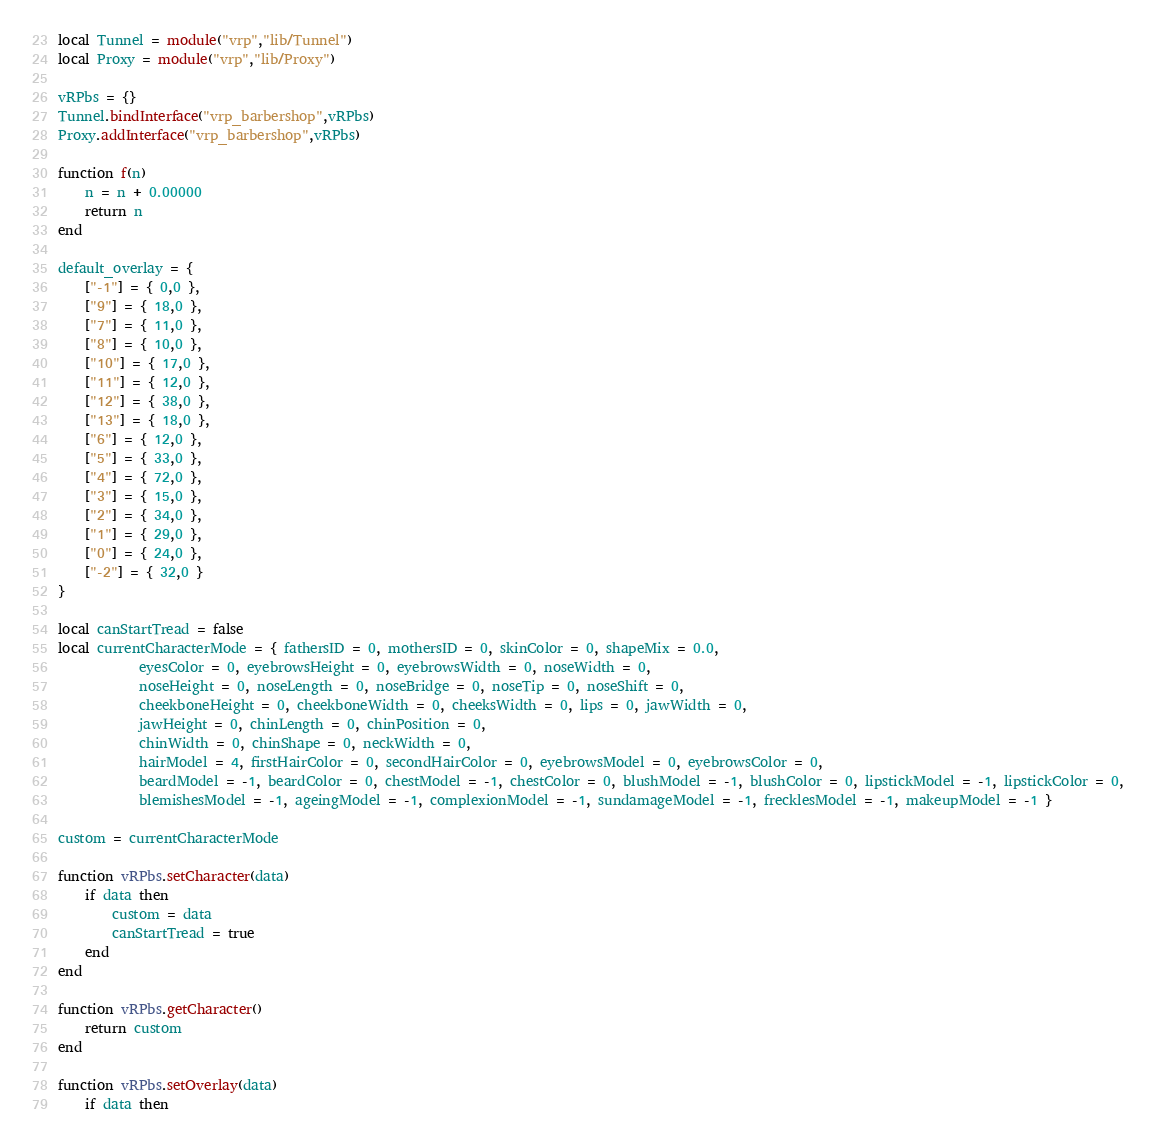<code> <loc_0><loc_0><loc_500><loc_500><_Lua_>local Tunnel = module("vrp","lib/Tunnel")
local Proxy = module("vrp","lib/Proxy")

vRPbs = {}
Tunnel.bindInterface("vrp_barbershop",vRPbs)
Proxy.addInterface("vrp_barbershop",vRPbs)

function f(n)
	n = n + 0.00000
	return n
end

default_overlay = {
	["-1"] = { 0,0 },
	["9"] = { 18,0 },
	["7"] = { 11,0 },
	["8"] = { 10,0 },
	["10"] = { 17,0 },
	["11"] = { 12,0 },
	["12"] = { 38,0 },
	["13"] = { 18,0 },
	["6"] = { 12,0 },
	["5"] = { 33,0 },
	["4"] = { 72,0 },
	["3"] = { 15,0 },
	["2"] = { 34,0 },
	["1"] = { 29,0 },
	["0"] = { 24,0 },
	["-2"] = { 32,0 }
}

local canStartTread = false
local currentCharacterMode = { fathersID = 0, mothersID = 0, skinColor = 0, shapeMix = 0.0,
            eyesColor = 0, eyebrowsHeight = 0, eyebrowsWidth = 0, noseWidth = 0,
            noseHeight = 0, noseLength = 0, noseBridge = 0, noseTip = 0, noseShift = 0,
            cheekboneHeight = 0, cheekboneWidth = 0, cheeksWidth = 0, lips = 0, jawWidth = 0,
            jawHeight = 0, chinLength = 0, chinPosition = 0,
            chinWidth = 0, chinShape = 0, neckWidth = 0,
            hairModel = 4, firstHairColor = 0, secondHairColor = 0, eyebrowsModel = 0, eyebrowsColor = 0,
            beardModel = -1, beardColor = 0, chestModel = -1, chestColor = 0, blushModel = -1, blushColor = 0, lipstickModel = -1, lipstickColor = 0,
            blemishesModel = -1, ageingModel = -1, complexionModel = -1, sundamageModel = -1, frecklesModel = -1, makeupModel = -1 }

custom = currentCharacterMode

function vRPbs.setCharacter(data)
	if data then
		custom = data
		canStartTread = true
	end
end

function vRPbs.getCharacter()
	return custom
end

function vRPbs.setOverlay(data)
	if data then</code> 